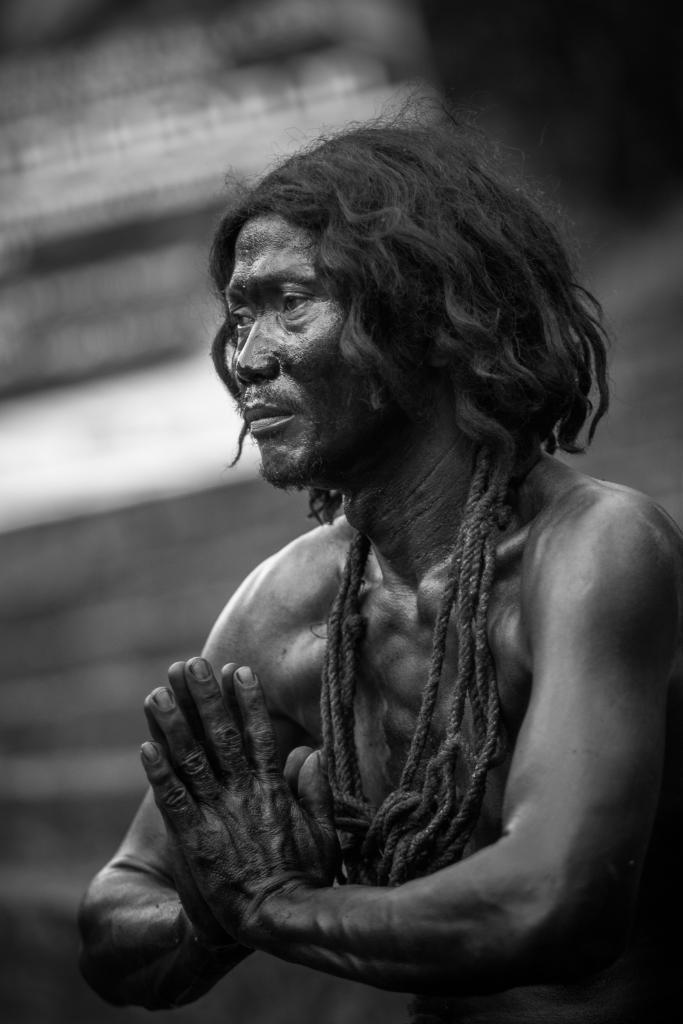Can you describe this image briefly? This is a black and white image. Here I can see a man facing towards the left side. There is a rope around his neck. The background is blurred. 